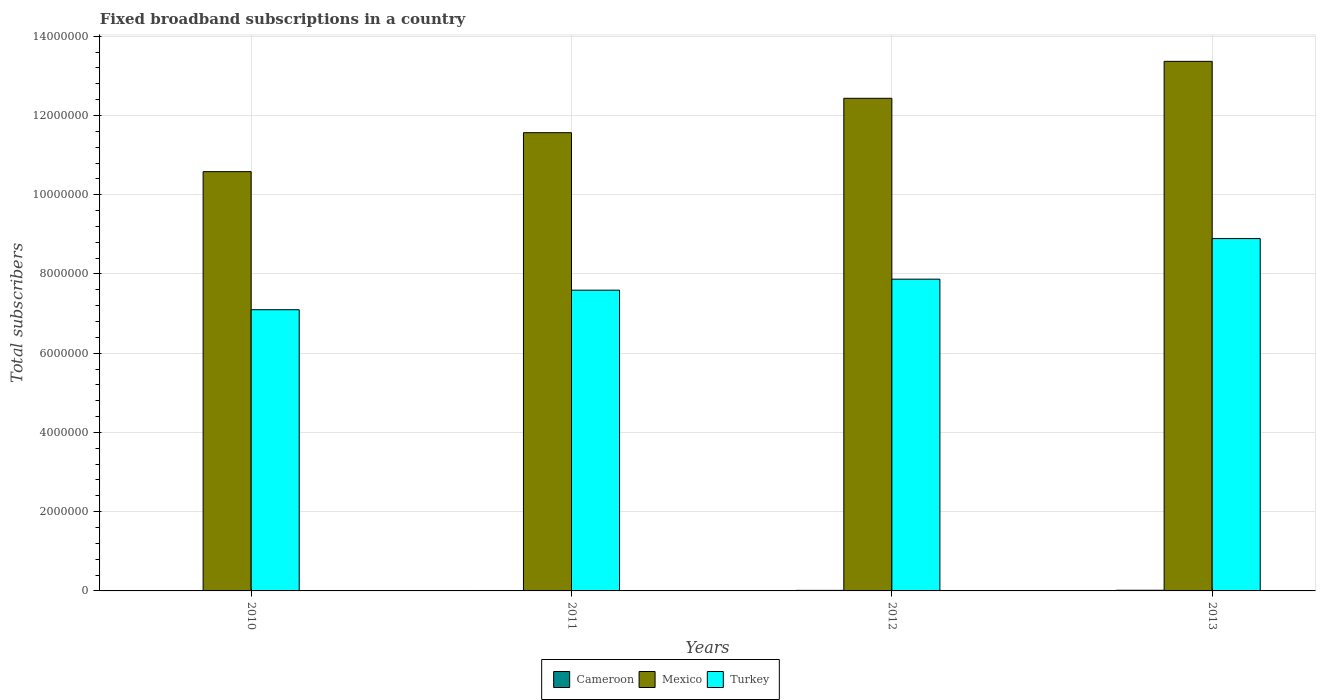What is the label of the 1st group of bars from the left?
Your answer should be very brief. 2010. What is the number of broadband subscriptions in Turkey in 2013?
Make the answer very short. 8.89e+06. Across all years, what is the maximum number of broadband subscriptions in Cameroon?
Provide a short and direct response. 1.69e+04. Across all years, what is the minimum number of broadband subscriptions in Turkey?
Your response must be concise. 7.10e+06. In which year was the number of broadband subscriptions in Mexico maximum?
Offer a terse response. 2013. What is the total number of broadband subscriptions in Cameroon in the graph?
Offer a terse response. 4.74e+04. What is the difference between the number of broadband subscriptions in Mexico in 2010 and that in 2012?
Your answer should be compact. -1.85e+06. What is the difference between the number of broadband subscriptions in Cameroon in 2010 and the number of broadband subscriptions in Turkey in 2013?
Offer a very short reply. -8.89e+06. What is the average number of broadband subscriptions in Turkey per year?
Offer a very short reply. 7.86e+06. In the year 2012, what is the difference between the number of broadband subscriptions in Cameroon and number of broadband subscriptions in Turkey?
Offer a very short reply. -7.86e+06. What is the ratio of the number of broadband subscriptions in Cameroon in 2011 to that in 2013?
Provide a short and direct response. 0.63. Is the difference between the number of broadband subscriptions in Cameroon in 2010 and 2011 greater than the difference between the number of broadband subscriptions in Turkey in 2010 and 2011?
Provide a short and direct response. Yes. What is the difference between the highest and the second highest number of broadband subscriptions in Turkey?
Make the answer very short. 1.02e+06. What is the difference between the highest and the lowest number of broadband subscriptions in Turkey?
Offer a terse response. 1.80e+06. Is it the case that in every year, the sum of the number of broadband subscriptions in Turkey and number of broadband subscriptions in Mexico is greater than the number of broadband subscriptions in Cameroon?
Offer a terse response. Yes. How many bars are there?
Provide a short and direct response. 12. How many years are there in the graph?
Offer a terse response. 4. Are the values on the major ticks of Y-axis written in scientific E-notation?
Offer a terse response. No. Where does the legend appear in the graph?
Ensure brevity in your answer.  Bottom center. How many legend labels are there?
Offer a terse response. 3. What is the title of the graph?
Your response must be concise. Fixed broadband subscriptions in a country. What is the label or title of the X-axis?
Your answer should be compact. Years. What is the label or title of the Y-axis?
Provide a short and direct response. Total subscribers. What is the Total subscribers in Cameroon in 2010?
Give a very brief answer. 5954. What is the Total subscribers in Mexico in 2010?
Your answer should be compact. 1.06e+07. What is the Total subscribers in Turkey in 2010?
Offer a terse response. 7.10e+06. What is the Total subscribers in Cameroon in 2011?
Your answer should be very brief. 1.07e+04. What is the Total subscribers in Mexico in 2011?
Provide a short and direct response. 1.16e+07. What is the Total subscribers of Turkey in 2011?
Offer a very short reply. 7.59e+06. What is the Total subscribers of Cameroon in 2012?
Your answer should be compact. 1.38e+04. What is the Total subscribers of Mexico in 2012?
Your answer should be compact. 1.24e+07. What is the Total subscribers of Turkey in 2012?
Provide a short and direct response. 7.87e+06. What is the Total subscribers of Cameroon in 2013?
Provide a succinct answer. 1.69e+04. What is the Total subscribers in Mexico in 2013?
Offer a terse response. 1.34e+07. What is the Total subscribers of Turkey in 2013?
Your answer should be very brief. 8.89e+06. Across all years, what is the maximum Total subscribers in Cameroon?
Provide a succinct answer. 1.69e+04. Across all years, what is the maximum Total subscribers in Mexico?
Give a very brief answer. 1.34e+07. Across all years, what is the maximum Total subscribers of Turkey?
Give a very brief answer. 8.89e+06. Across all years, what is the minimum Total subscribers in Cameroon?
Offer a terse response. 5954. Across all years, what is the minimum Total subscribers in Mexico?
Your answer should be compact. 1.06e+07. Across all years, what is the minimum Total subscribers of Turkey?
Provide a succinct answer. 7.10e+06. What is the total Total subscribers in Cameroon in the graph?
Give a very brief answer. 4.74e+04. What is the total Total subscribers in Mexico in the graph?
Offer a very short reply. 4.79e+07. What is the total Total subscribers of Turkey in the graph?
Make the answer very short. 3.15e+07. What is the difference between the Total subscribers in Cameroon in 2010 and that in 2011?
Your answer should be very brief. -4759. What is the difference between the Total subscribers of Mexico in 2010 and that in 2011?
Offer a terse response. -9.83e+05. What is the difference between the Total subscribers of Turkey in 2010 and that in 2011?
Your answer should be very brief. -4.93e+05. What is the difference between the Total subscribers of Cameroon in 2010 and that in 2012?
Offer a terse response. -7892. What is the difference between the Total subscribers of Mexico in 2010 and that in 2012?
Offer a very short reply. -1.85e+06. What is the difference between the Total subscribers in Turkey in 2010 and that in 2012?
Offer a very short reply. -7.71e+05. What is the difference between the Total subscribers of Cameroon in 2010 and that in 2013?
Provide a short and direct response. -1.09e+04. What is the difference between the Total subscribers of Mexico in 2010 and that in 2013?
Make the answer very short. -2.78e+06. What is the difference between the Total subscribers of Turkey in 2010 and that in 2013?
Offer a very short reply. -1.80e+06. What is the difference between the Total subscribers of Cameroon in 2011 and that in 2012?
Make the answer very short. -3133. What is the difference between the Total subscribers in Mexico in 2011 and that in 2012?
Ensure brevity in your answer.  -8.68e+05. What is the difference between the Total subscribers of Turkey in 2011 and that in 2012?
Offer a very short reply. -2.78e+05. What is the difference between the Total subscribers in Cameroon in 2011 and that in 2013?
Keep it short and to the point. -6187. What is the difference between the Total subscribers of Mexico in 2011 and that in 2013?
Provide a succinct answer. -1.80e+06. What is the difference between the Total subscribers in Turkey in 2011 and that in 2013?
Ensure brevity in your answer.  -1.30e+06. What is the difference between the Total subscribers of Cameroon in 2012 and that in 2013?
Offer a terse response. -3054. What is the difference between the Total subscribers of Mexico in 2012 and that in 2013?
Provide a succinct answer. -9.33e+05. What is the difference between the Total subscribers in Turkey in 2012 and that in 2013?
Give a very brief answer. -1.02e+06. What is the difference between the Total subscribers in Cameroon in 2010 and the Total subscribers in Mexico in 2011?
Your response must be concise. -1.16e+07. What is the difference between the Total subscribers of Cameroon in 2010 and the Total subscribers of Turkey in 2011?
Keep it short and to the point. -7.59e+06. What is the difference between the Total subscribers in Mexico in 2010 and the Total subscribers in Turkey in 2011?
Keep it short and to the point. 2.99e+06. What is the difference between the Total subscribers in Cameroon in 2010 and the Total subscribers in Mexico in 2012?
Offer a terse response. -1.24e+07. What is the difference between the Total subscribers in Cameroon in 2010 and the Total subscribers in Turkey in 2012?
Ensure brevity in your answer.  -7.86e+06. What is the difference between the Total subscribers in Mexico in 2010 and the Total subscribers in Turkey in 2012?
Provide a succinct answer. 2.71e+06. What is the difference between the Total subscribers in Cameroon in 2010 and the Total subscribers in Mexico in 2013?
Your response must be concise. -1.34e+07. What is the difference between the Total subscribers in Cameroon in 2010 and the Total subscribers in Turkey in 2013?
Your answer should be compact. -8.89e+06. What is the difference between the Total subscribers in Mexico in 2010 and the Total subscribers in Turkey in 2013?
Provide a succinct answer. 1.69e+06. What is the difference between the Total subscribers of Cameroon in 2011 and the Total subscribers of Mexico in 2012?
Your answer should be very brief. -1.24e+07. What is the difference between the Total subscribers in Cameroon in 2011 and the Total subscribers in Turkey in 2012?
Provide a succinct answer. -7.86e+06. What is the difference between the Total subscribers in Mexico in 2011 and the Total subscribers in Turkey in 2012?
Offer a terse response. 3.70e+06. What is the difference between the Total subscribers in Cameroon in 2011 and the Total subscribers in Mexico in 2013?
Offer a very short reply. -1.34e+07. What is the difference between the Total subscribers of Cameroon in 2011 and the Total subscribers of Turkey in 2013?
Your answer should be compact. -8.88e+06. What is the difference between the Total subscribers of Mexico in 2011 and the Total subscribers of Turkey in 2013?
Offer a terse response. 2.67e+06. What is the difference between the Total subscribers of Cameroon in 2012 and the Total subscribers of Mexico in 2013?
Give a very brief answer. -1.34e+07. What is the difference between the Total subscribers of Cameroon in 2012 and the Total subscribers of Turkey in 2013?
Make the answer very short. -8.88e+06. What is the difference between the Total subscribers of Mexico in 2012 and the Total subscribers of Turkey in 2013?
Provide a short and direct response. 3.54e+06. What is the average Total subscribers in Cameroon per year?
Keep it short and to the point. 1.19e+04. What is the average Total subscribers of Mexico per year?
Ensure brevity in your answer.  1.20e+07. What is the average Total subscribers of Turkey per year?
Make the answer very short. 7.86e+06. In the year 2010, what is the difference between the Total subscribers of Cameroon and Total subscribers of Mexico?
Provide a succinct answer. -1.06e+07. In the year 2010, what is the difference between the Total subscribers of Cameroon and Total subscribers of Turkey?
Ensure brevity in your answer.  -7.09e+06. In the year 2010, what is the difference between the Total subscribers of Mexico and Total subscribers of Turkey?
Offer a very short reply. 3.48e+06. In the year 2011, what is the difference between the Total subscribers in Cameroon and Total subscribers in Mexico?
Make the answer very short. -1.16e+07. In the year 2011, what is the difference between the Total subscribers in Cameroon and Total subscribers in Turkey?
Your response must be concise. -7.58e+06. In the year 2011, what is the difference between the Total subscribers in Mexico and Total subscribers in Turkey?
Your answer should be compact. 3.97e+06. In the year 2012, what is the difference between the Total subscribers in Cameroon and Total subscribers in Mexico?
Provide a succinct answer. -1.24e+07. In the year 2012, what is the difference between the Total subscribers of Cameroon and Total subscribers of Turkey?
Offer a terse response. -7.86e+06. In the year 2012, what is the difference between the Total subscribers of Mexico and Total subscribers of Turkey?
Provide a short and direct response. 4.57e+06. In the year 2013, what is the difference between the Total subscribers in Cameroon and Total subscribers in Mexico?
Give a very brief answer. -1.33e+07. In the year 2013, what is the difference between the Total subscribers in Cameroon and Total subscribers in Turkey?
Provide a short and direct response. -8.88e+06. In the year 2013, what is the difference between the Total subscribers in Mexico and Total subscribers in Turkey?
Give a very brief answer. 4.47e+06. What is the ratio of the Total subscribers in Cameroon in 2010 to that in 2011?
Provide a succinct answer. 0.56. What is the ratio of the Total subscribers of Mexico in 2010 to that in 2011?
Provide a short and direct response. 0.92. What is the ratio of the Total subscribers of Turkey in 2010 to that in 2011?
Ensure brevity in your answer.  0.94. What is the ratio of the Total subscribers in Cameroon in 2010 to that in 2012?
Offer a terse response. 0.43. What is the ratio of the Total subscribers in Mexico in 2010 to that in 2012?
Ensure brevity in your answer.  0.85. What is the ratio of the Total subscribers of Turkey in 2010 to that in 2012?
Offer a terse response. 0.9. What is the ratio of the Total subscribers in Cameroon in 2010 to that in 2013?
Give a very brief answer. 0.35. What is the ratio of the Total subscribers in Mexico in 2010 to that in 2013?
Ensure brevity in your answer.  0.79. What is the ratio of the Total subscribers in Turkey in 2010 to that in 2013?
Ensure brevity in your answer.  0.8. What is the ratio of the Total subscribers in Cameroon in 2011 to that in 2012?
Your answer should be compact. 0.77. What is the ratio of the Total subscribers of Mexico in 2011 to that in 2012?
Offer a terse response. 0.93. What is the ratio of the Total subscribers of Turkey in 2011 to that in 2012?
Provide a short and direct response. 0.96. What is the ratio of the Total subscribers in Cameroon in 2011 to that in 2013?
Offer a very short reply. 0.63. What is the ratio of the Total subscribers of Mexico in 2011 to that in 2013?
Give a very brief answer. 0.87. What is the ratio of the Total subscribers of Turkey in 2011 to that in 2013?
Keep it short and to the point. 0.85. What is the ratio of the Total subscribers in Cameroon in 2012 to that in 2013?
Give a very brief answer. 0.82. What is the ratio of the Total subscribers in Mexico in 2012 to that in 2013?
Provide a succinct answer. 0.93. What is the ratio of the Total subscribers in Turkey in 2012 to that in 2013?
Offer a terse response. 0.88. What is the difference between the highest and the second highest Total subscribers of Cameroon?
Provide a short and direct response. 3054. What is the difference between the highest and the second highest Total subscribers in Mexico?
Provide a short and direct response. 9.33e+05. What is the difference between the highest and the second highest Total subscribers of Turkey?
Keep it short and to the point. 1.02e+06. What is the difference between the highest and the lowest Total subscribers in Cameroon?
Ensure brevity in your answer.  1.09e+04. What is the difference between the highest and the lowest Total subscribers of Mexico?
Keep it short and to the point. 2.78e+06. What is the difference between the highest and the lowest Total subscribers of Turkey?
Your response must be concise. 1.80e+06. 